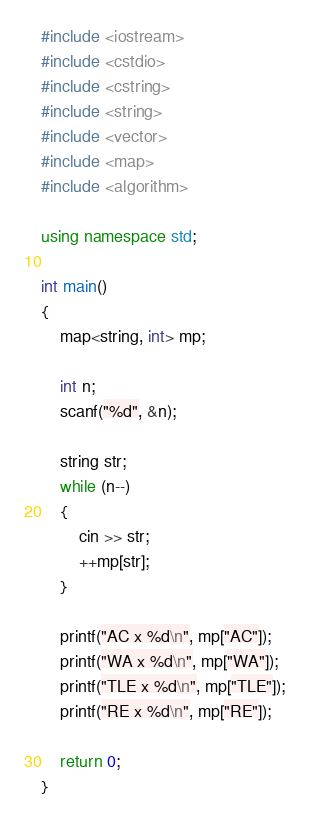Convert code to text. <code><loc_0><loc_0><loc_500><loc_500><_C++_>#include <iostream>
#include <cstdio>
#include <cstring>
#include <string>
#include <vector>
#include <map>
#include <algorithm>

using namespace std;

int main()
{
	map<string, int> mp;

	int n;
	scanf("%d", &n);

	string str;
	while (n--)
	{
		cin >> str;
		++mp[str];
	}

	printf("AC x %d\n", mp["AC"]);
	printf("WA x %d\n", mp["WA"]);
	printf("TLE x %d\n", mp["TLE"]);
	printf("RE x %d\n", mp["RE"]);

	return 0;
}
</code> 